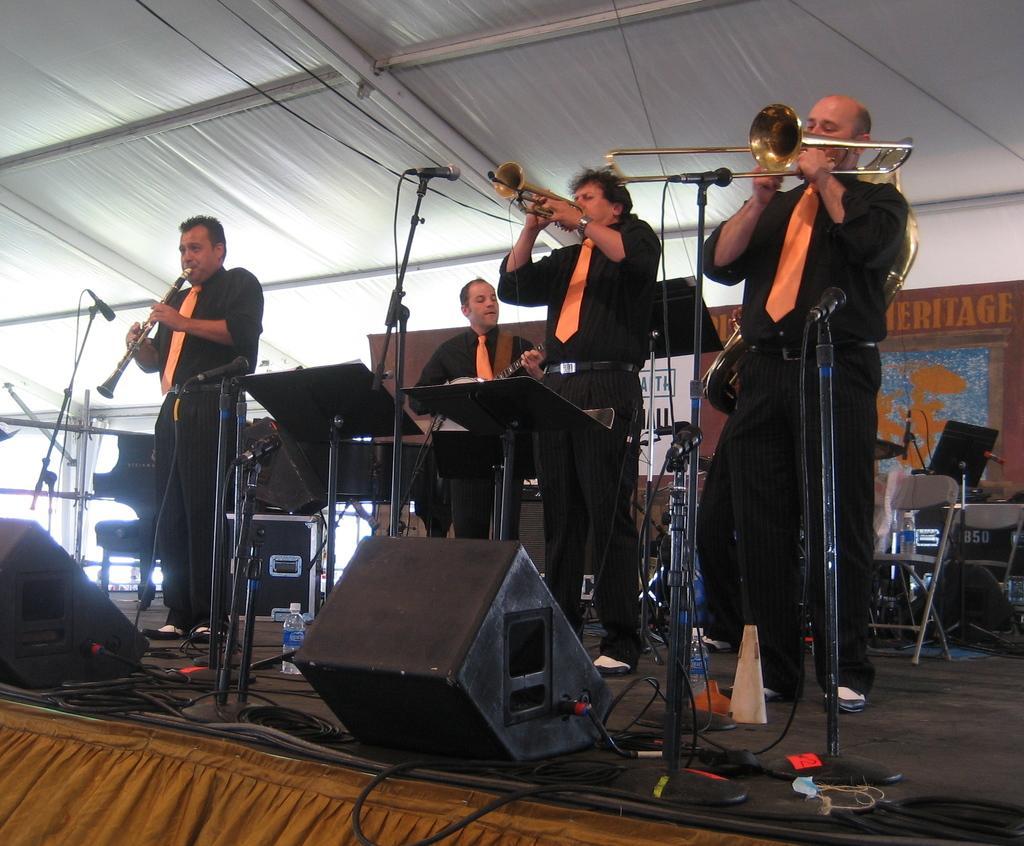How would you summarize this image in a sentence or two? This picture describe about the group of men wearing black shirt and orange color tie performing a music show on the stage. In front we can see some big black color speakers some music systems on the stage. Above we can see the white color cloth tent. 